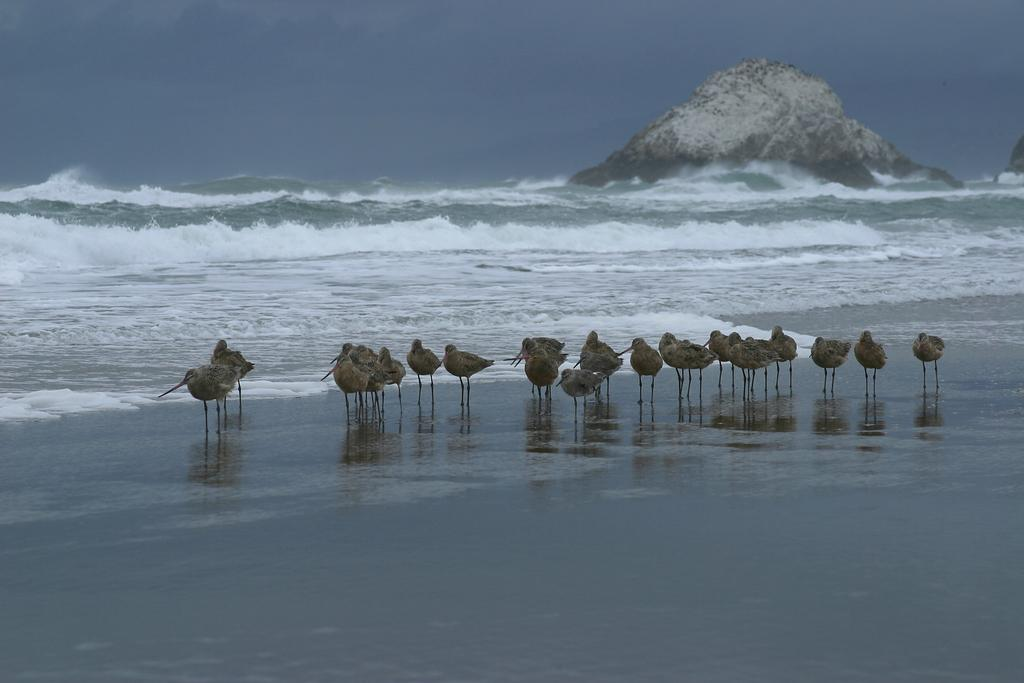What type of animals can be seen in the image? Birds can be seen in the image. What is the primary element in which the birds are situated? The birds are situated in water. What is the condition of the sky in the image? The sky is cloudy in the image. What natural feature is present in the image? There is a rock in the image. What type of tools does the carpenter use in the image? There is no carpenter present in the image, so it is not possible to determine what tools they might use. 